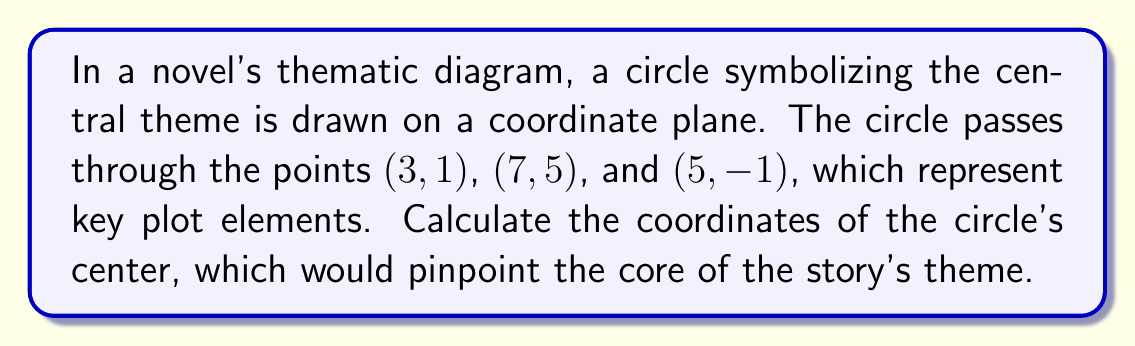Help me with this question. Let's approach this step-by-step:

1) The center of a circle is equidistant from any point on the circumference. We can use this property to find the center.

2) Let the center be $(h, k)$. We can use the general equation of a circle:
   $$(x - h)^2 + (y - k)^2 = r^2$$
   where $r$ is the radius.

3) We have three points on the circle. Let's use two equations:
   $$(3 - h)^2 + (1 - k)^2 = r^2 \quad (1)$$
   $$(7 - h)^2 + (5 - k)^2 = r^2 \quad (2)$$

4) Subtracting (1) from (2):
   $$(7 - h)^2 + (5 - k)^2 - [(3 - h)^2 + (1 - k)^2] = 0$$

5) Expanding:
   $$49 - 14h + h^2 + 25 - 10k + k^2 - [9 - 6h + h^2 + 1 - 2k + k^2] = 0$$

6) Simplifying:
   $$64 - 8h - 8k = 0 \quad (3)$$

7) Similarly, using points $(3, 1)$ and $(5, -1)$:
   $$(5 - h)^2 + (-1 - k)^2 - [(3 - h)^2 + (1 - k)^2] = 0$$
   $$25 - 10h + h^2 + 1 + 2k + k^2 - [9 - 6h + h^2 + 1 - 2k + k^2] = 0$$
   $$16 - 4h + 4k = 0 \quad (4)$$

8) From (3): $h = 8 - k$
   Substituting in (4):
   $$16 - 4(8 - k) + 4k = 0$$
   $$16 - 32 + 4k + 4k = 0$$
   $$8k = 16$$
   $$k = 2$$

9) Substituting back:
   $$h = 8 - 2 = 6$$

Therefore, the center coordinates are $(6, 2)$.
Answer: $(6, 2)$ 